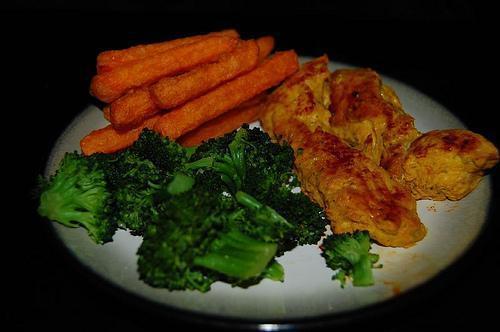How many broccolis are in the photo?
Give a very brief answer. 2. 